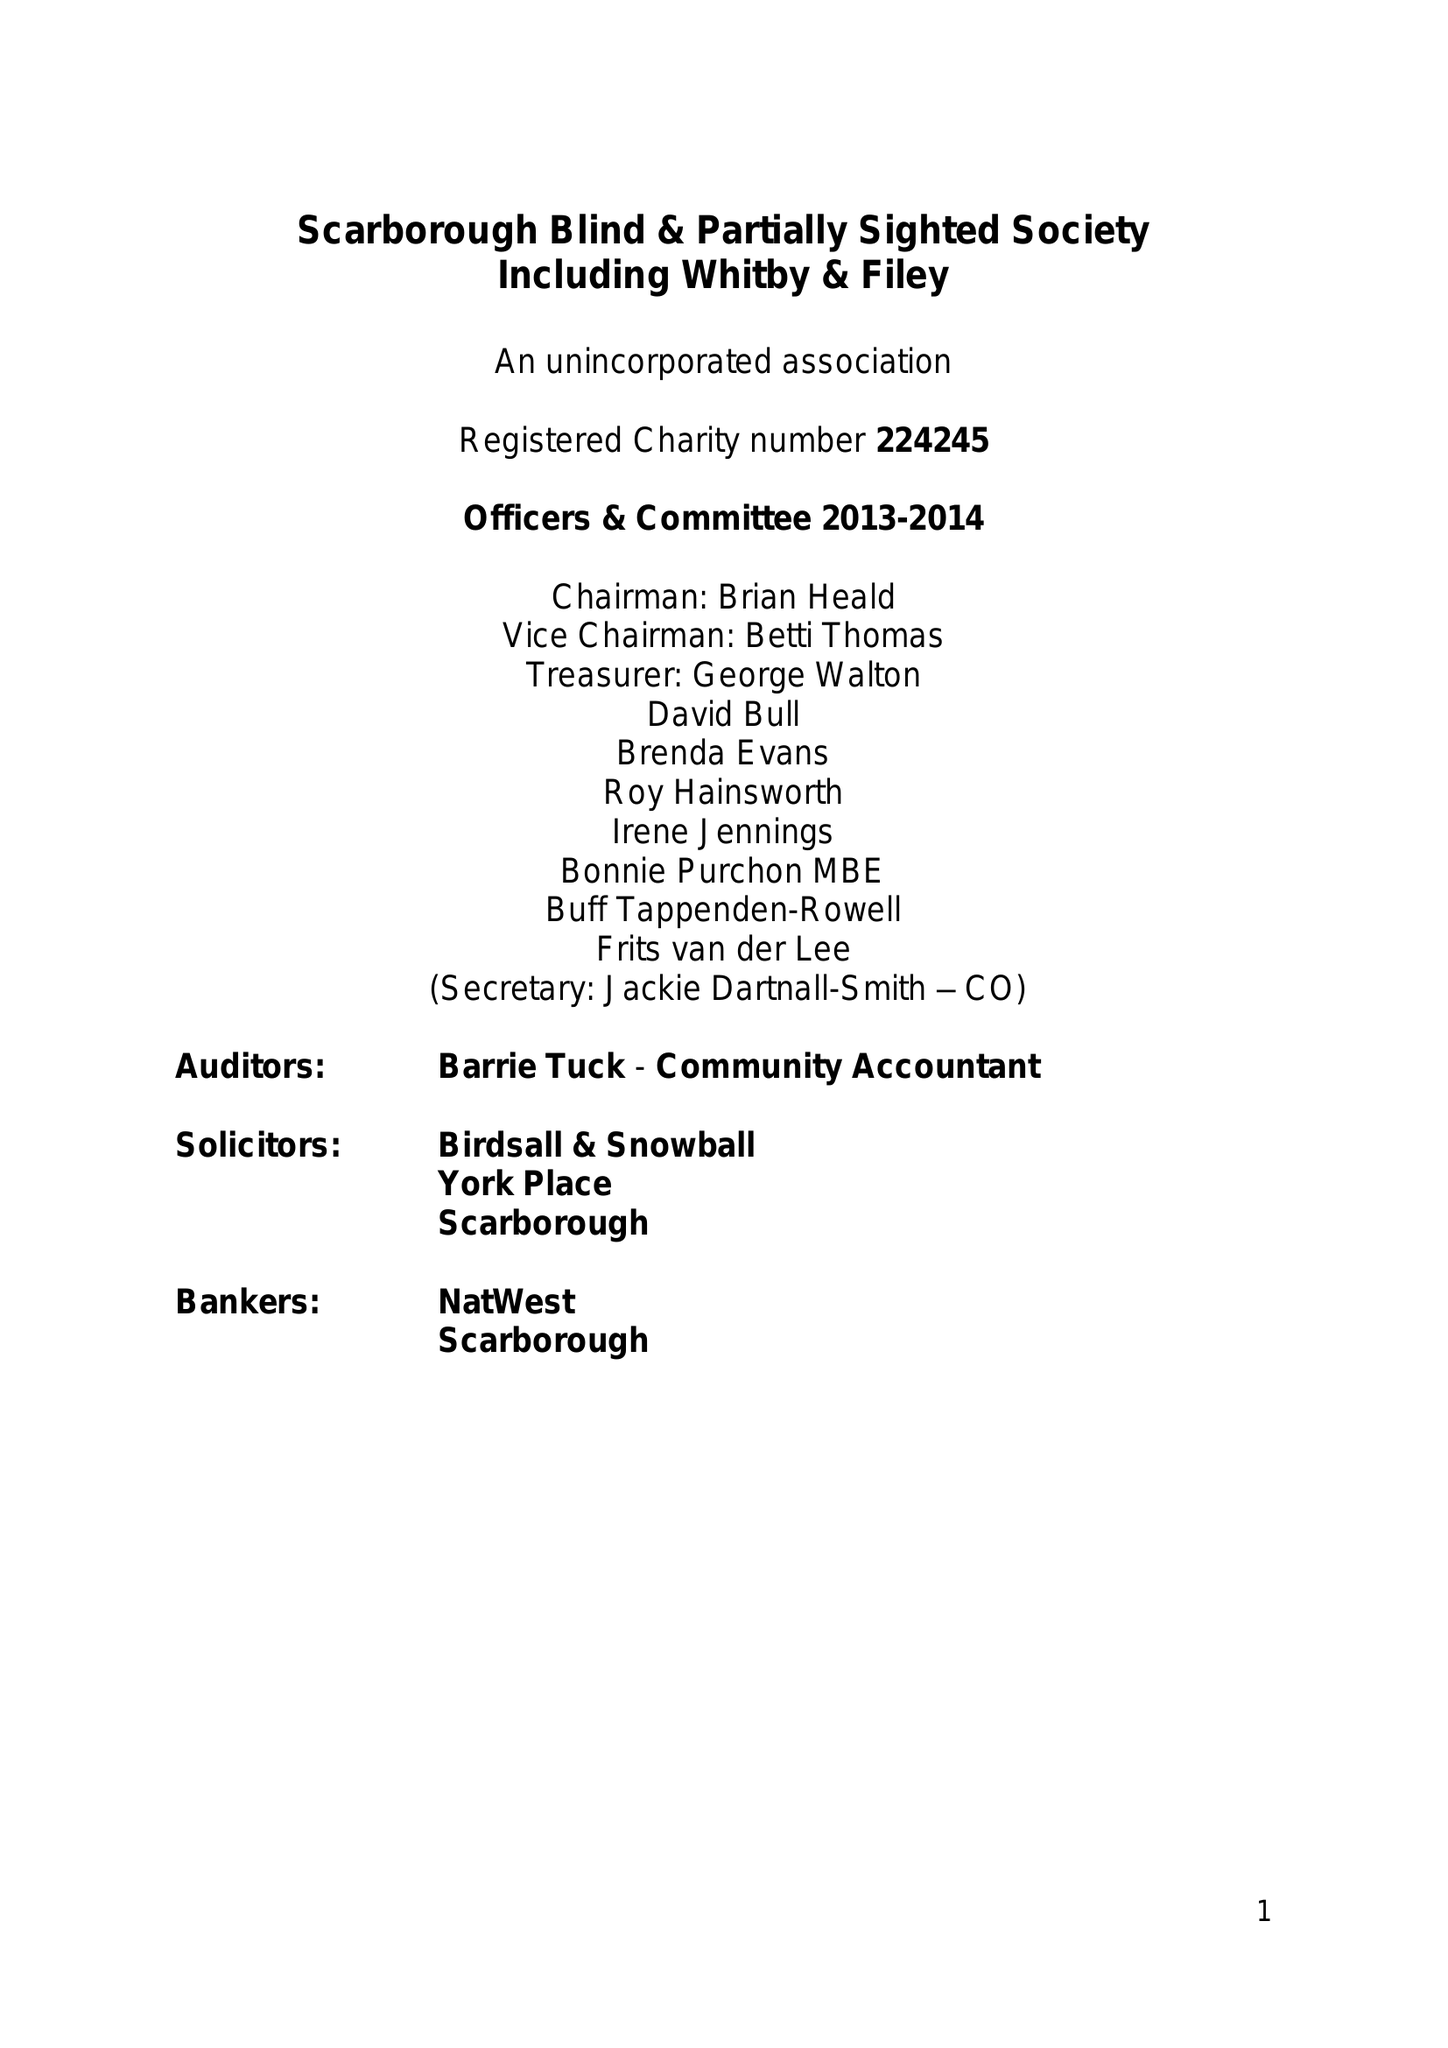What is the value for the charity_number?
Answer the question using a single word or phrase. 224245 